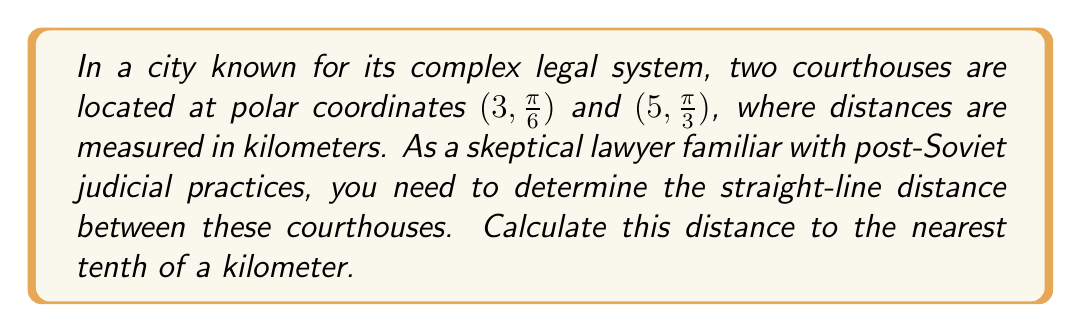Solve this math problem. To solve this problem, we'll use the formula for the distance between two points in polar coordinates:

$$d = \sqrt{r_1^2 + r_2^2 - 2r_1r_2\cos(\theta_2 - \theta_1)}$$

Where:
$(r_1, \theta_1)$ is the first point
$(r_2, \theta_2)$ is the second point

Step 1: Identify the given coordinates:
Point 1: $(r_1, \theta_1) = (3, \frac{\pi}{6})$
Point 2: $(r_2, \theta_2) = (5, \frac{\pi}{3})$

Step 2: Calculate $\theta_2 - \theta_1$:
$$\theta_2 - \theta_1 = \frac{\pi}{3} - \frac{\pi}{6} = \frac{\pi}{6}$$

Step 3: Substitute the values into the distance formula:
$$\begin{align*}
d &= \sqrt{3^2 + 5^2 - 2(3)(5)\cos(\frac{\pi}{6})} \\
&= \sqrt{9 + 25 - 30\cos(\frac{\pi}{6})}
\end{align*}$$

Step 4: Calculate $\cos(\frac{\pi}{6})$:
$$\cos(\frac{\pi}{6}) = \frac{\sqrt{3}}{2}$$

Step 5: Substitute and simplify:
$$\begin{align*}
d &= \sqrt{34 - 30(\frac{\sqrt{3}}{2})} \\
&= \sqrt{34 - 15\sqrt{3}}
\end{align*}$$

Step 6: Use a calculator to evaluate and round to the nearest tenth:
$$d \approx 4.3 \text{ km}$$

[asy]
import geometry;

unitsize(30);
draw(circle((0,0),5));
draw((-5.5,0)--(5.5,0),arrow=Arrow(TeXHead));
draw((0,-5.5)--(0,5.5),arrow=Arrow(TeXHead));

dot((3*cos(pi/6),3*sin(pi/6)));
dot((5*cos(pi/3),5*sin(pi/3)));

label("(3, π/6)", (3*cos(pi/6),3*sin(pi/6)), SE);
label("(5, π/3)", (5*cos(pi/3),5*sin(pi/3)), NW);

draw((3*cos(pi/6),3*sin(pi/6))--(5*cos(pi/3),5*sin(pi/3)), dashed);
[/asy]
Answer: The distance between the two courthouses is approximately 4.3 km. 